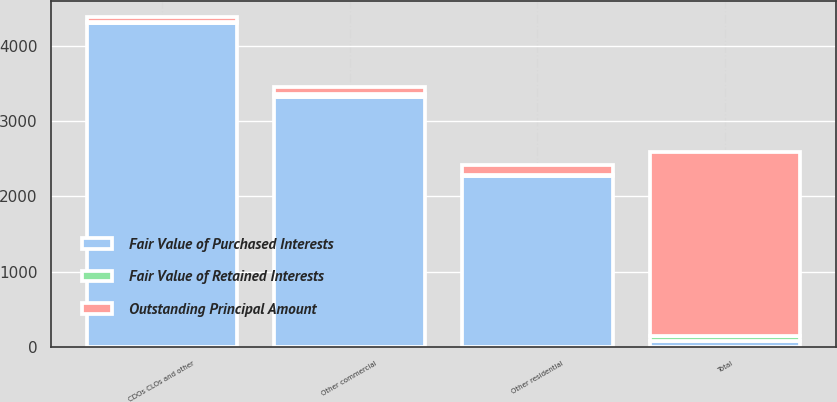<chart> <loc_0><loc_0><loc_500><loc_500><stacked_bar_chart><ecel><fcel>Other residential<fcel>Other commercial<fcel>CDOs CLOs and other<fcel>Total<nl><fcel>Fair Value of Purchased Interests<fcel>2273<fcel>3313<fcel>4299<fcel>86<nl><fcel>Outstanding Principal Amount<fcel>144<fcel>86<fcel>59<fcel>2429<nl><fcel>Fair Value of Retained Interests<fcel>5<fcel>45<fcel>17<fcel>67<nl></chart> 